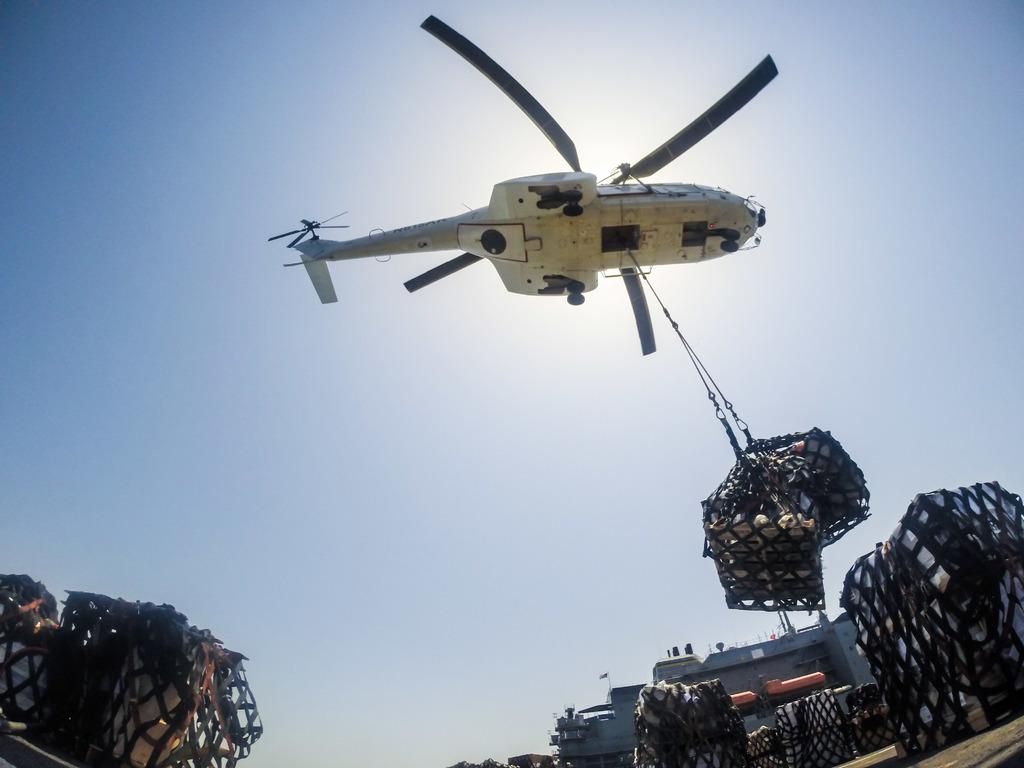What is the main subject of the image? The main subject of the image is an aircraft. Can you describe the color of the aircraft? The aircraft is white. What else can be seen in the image besides the aircraft? There are objects in a net and a building in the background of the image. How would you describe the building in the background? The building is gray. What is visible in the background of the image? The sky is visible in the background of the image. What colors can be seen in the sky? The sky is blue and white. Can you see a stream of water flowing near the aircraft in the image? There is no stream of water visible in the image. Is the aircraft burning in the image? The aircraft is not burning in the image; it is stationary and white. 